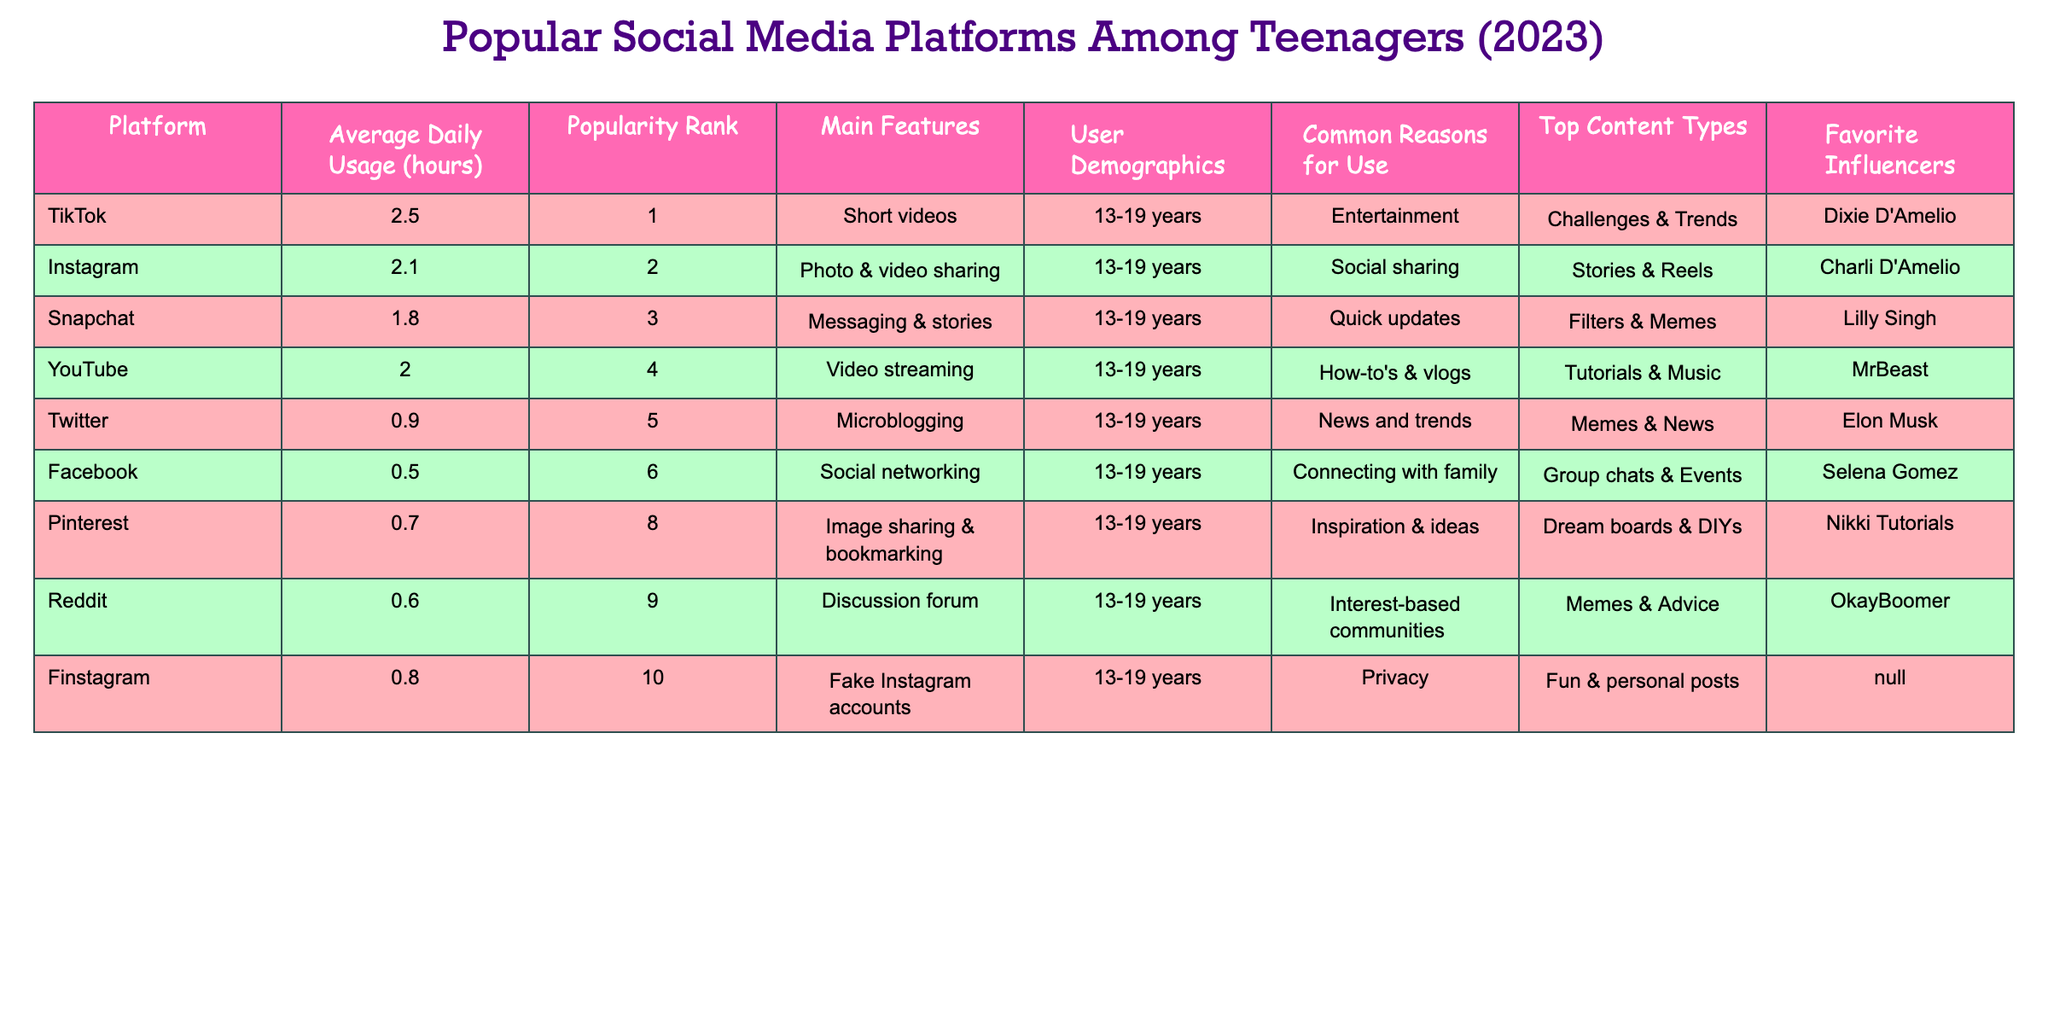What is the most popular social media platform among teenagers in 2023? According to the table, TikTok has the highest popularity rank of 1 among the listed platforms.
Answer: TikTok How many hours per day do teenagers spend on Instagram? The table shows that the average daily usage for Instagram is 2.1 hours.
Answer: 2.1 hours Which platform has the lowest average daily usage? By checking the average daily usage column, Facebook has the lowest average daily usage of 0.5 hours.
Answer: Facebook Are tutorials & music among the top content types for YouTube? The table indicates that tutorials & music are indeed listed as the top content types for YouTube.
Answer: Yes What is the difference in average daily usage between TikTok and Twitter? TikTok averages 2.5 hours and Twitter averages 0.9 hours, so the difference is 2.5 - 0.9 = 1.6 hours.
Answer: 1.6 hours Which influencer is associated with Snapchat? The table lists Lilly Singh as the favorite influencer for Snapchat.
Answer: Lilly Singh How many platforms have an average usage of more than 2 hours? The platforms with more than 2 hours of usage are TikTok and YouTube, making a total of 2 platforms.
Answer: 2 Is Instagram more popular than Snapchat according to the popularity rank? Yes, Instagram has a popularity rank of 2, while Snapchat is ranked 3, making Instagram more popular.
Answer: Yes What is the average daily usage of all the listed platforms? Adding up the average daily usage gives: 2.5 + 2.1 + 1.8 + 2.0 + 0.9 + 0.5 + 0.7 + 0.6 + 0.8 = 11.9 hours. There are 9 platforms, so the average is 11.9 / 9 = 1.32 hours.
Answer: 1.32 hours Which platform is primarily used for messaging and stories? The table specifies that Snapchat is designed for messaging & stories.
Answer: Snapchat 